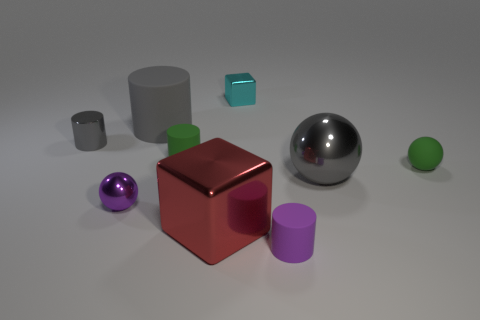Subtract 1 cylinders. How many cylinders are left? 3 Add 1 cyan metal things. How many objects exist? 10 Subtract all cubes. How many objects are left? 7 Subtract 0 brown cylinders. How many objects are left? 9 Subtract all red objects. Subtract all small green metal cubes. How many objects are left? 8 Add 3 large rubber objects. How many large rubber objects are left? 4 Add 8 large purple objects. How many large purple objects exist? 8 